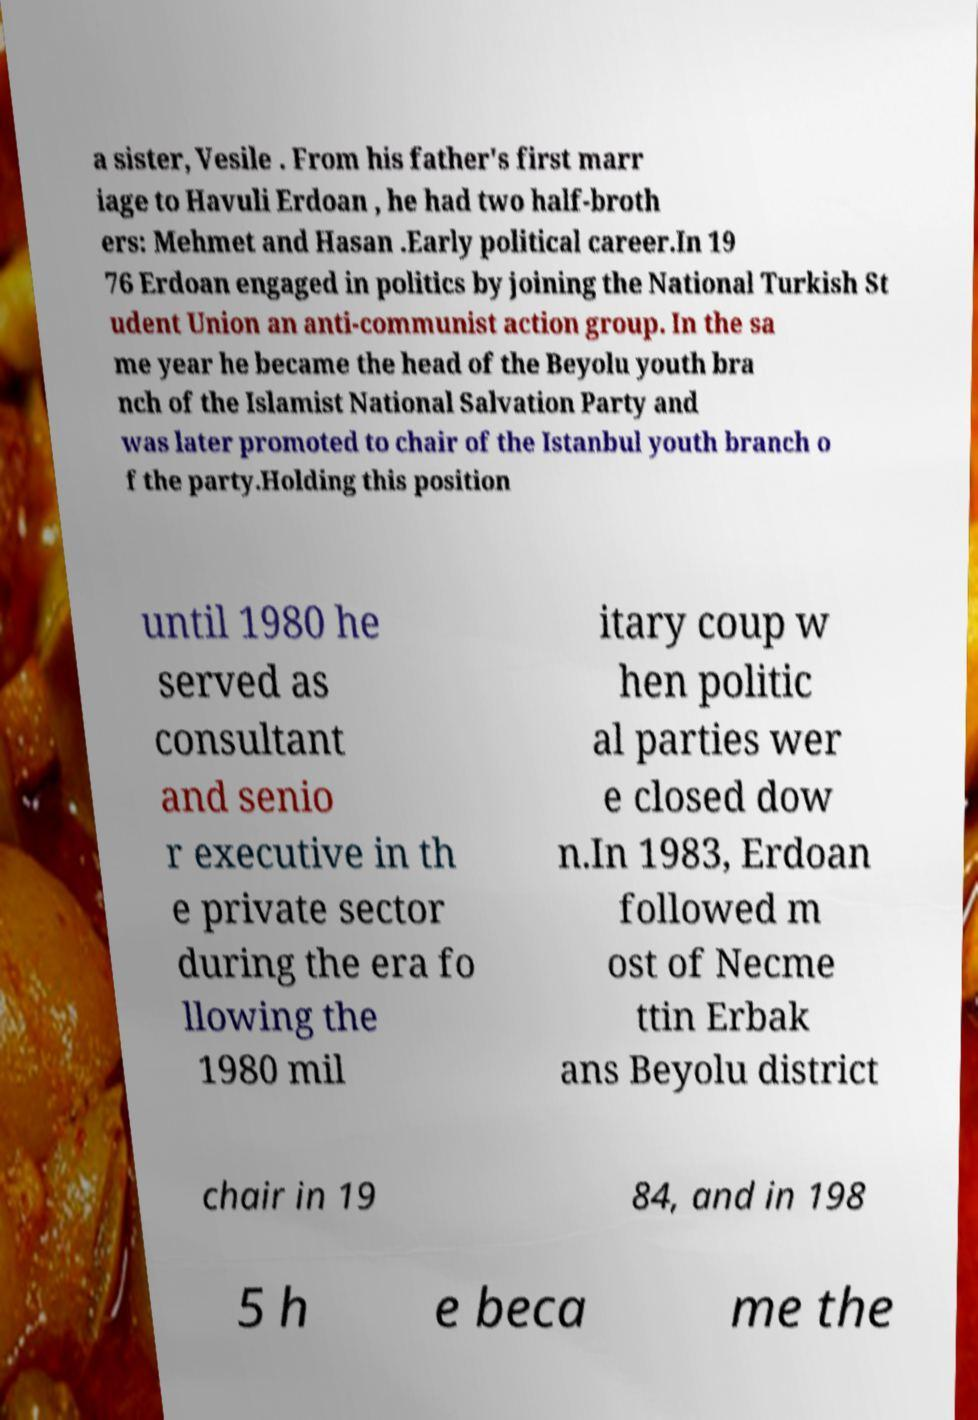Please identify and transcribe the text found in this image. a sister, Vesile . From his father's first marr iage to Havuli Erdoan , he had two half-broth ers: Mehmet and Hasan .Early political career.In 19 76 Erdoan engaged in politics by joining the National Turkish St udent Union an anti-communist action group. In the sa me year he became the head of the Beyolu youth bra nch of the Islamist National Salvation Party and was later promoted to chair of the Istanbul youth branch o f the party.Holding this position until 1980 he served as consultant and senio r executive in th e private sector during the era fo llowing the 1980 mil itary coup w hen politic al parties wer e closed dow n.In 1983, Erdoan followed m ost of Necme ttin Erbak ans Beyolu district chair in 19 84, and in 198 5 h e beca me the 